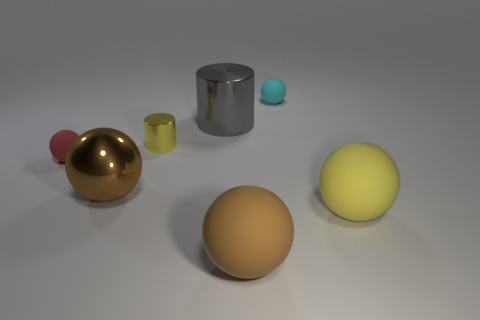Do the metallic thing in front of the red matte ball and the cyan matte ball behind the tiny yellow metallic cylinder have the same size?
Your answer should be very brief. No. There is a large thing that is behind the shiny sphere that is in front of the metallic object to the right of the small cylinder; what is its material?
Your answer should be compact. Metal. Do the cyan matte thing and the gray metallic object have the same shape?
Your answer should be compact. No. What is the material of the other brown object that is the same shape as the brown rubber object?
Ensure brevity in your answer.  Metal. How many matte things have the same color as the small metallic cylinder?
Keep it short and to the point. 1. There is a brown thing that is made of the same material as the yellow ball; what is its size?
Provide a short and direct response. Large. What number of cyan objects are rubber things or shiny spheres?
Your response must be concise. 1. There is a small object behind the big metallic cylinder; how many tiny cyan things are left of it?
Offer a very short reply. 0. Are there more big metal things that are in front of the big metallic cylinder than large metallic objects that are to the right of the small cyan rubber object?
Your response must be concise. Yes. What material is the tiny yellow cylinder?
Ensure brevity in your answer.  Metal. 